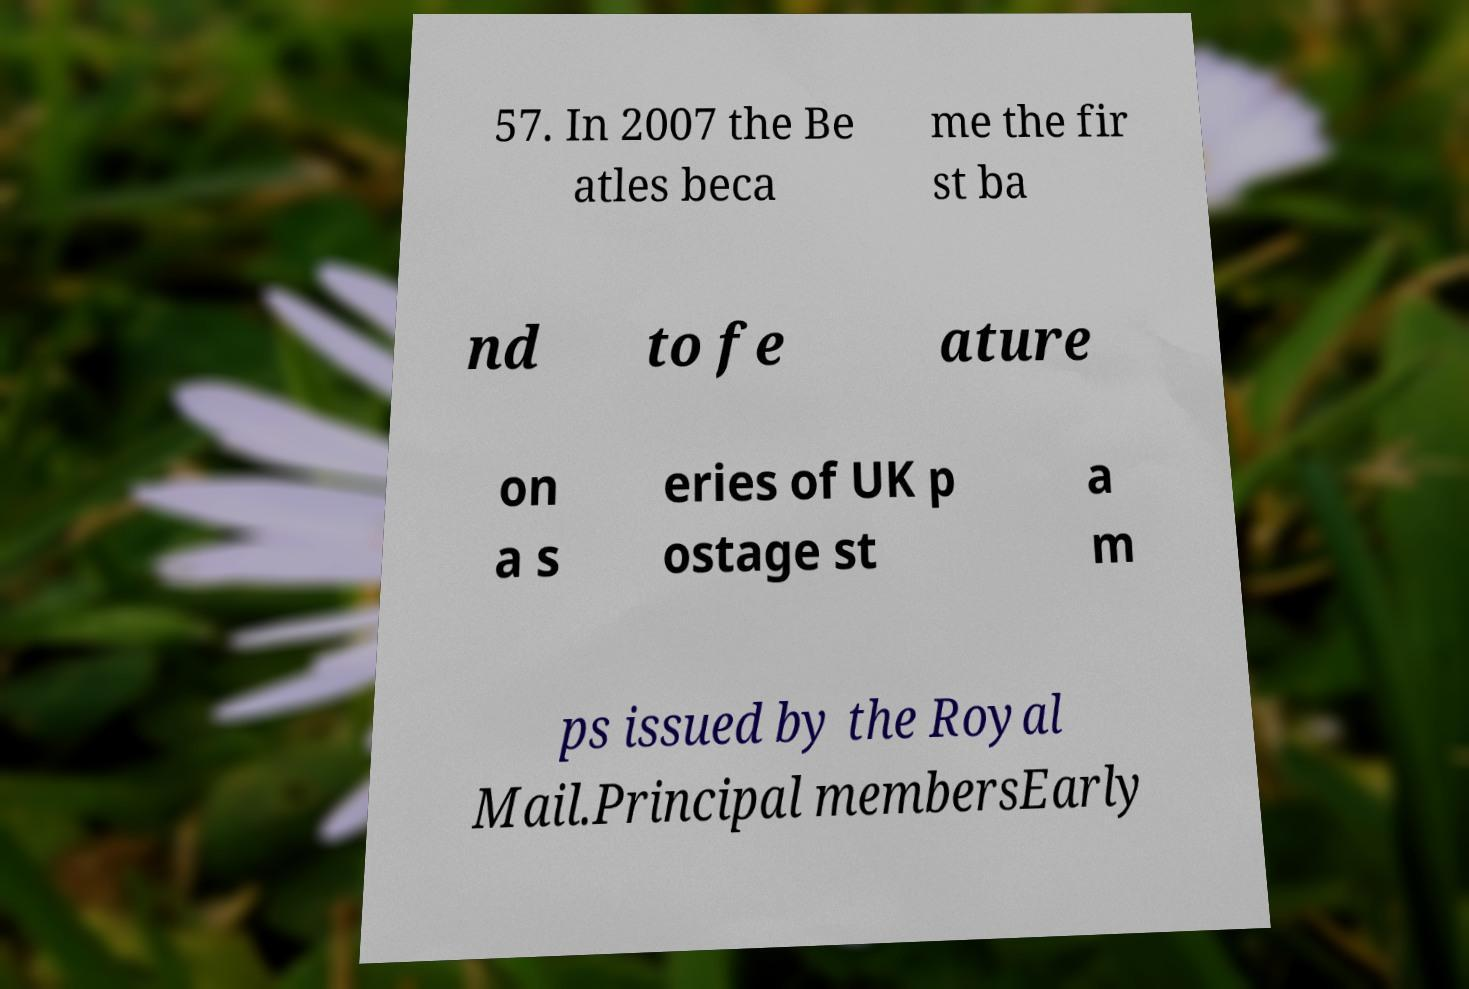What messages or text are displayed in this image? I need them in a readable, typed format. 57. In 2007 the Be atles beca me the fir st ba nd to fe ature on a s eries of UK p ostage st a m ps issued by the Royal Mail.Principal membersEarly 